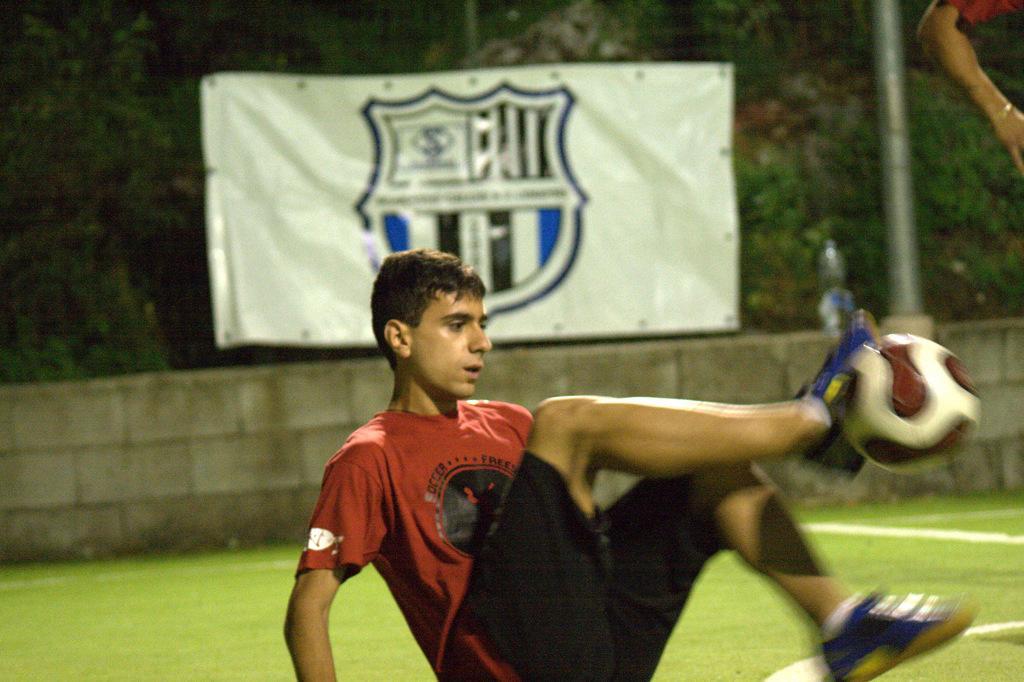In one or two sentences, can you explain what this image depicts? In this image on the ground a player is playing football. This is the football. In the background there is banner. There is boundary around the field. In the background there is pole, trees. On the top right we can see hand of a person. 